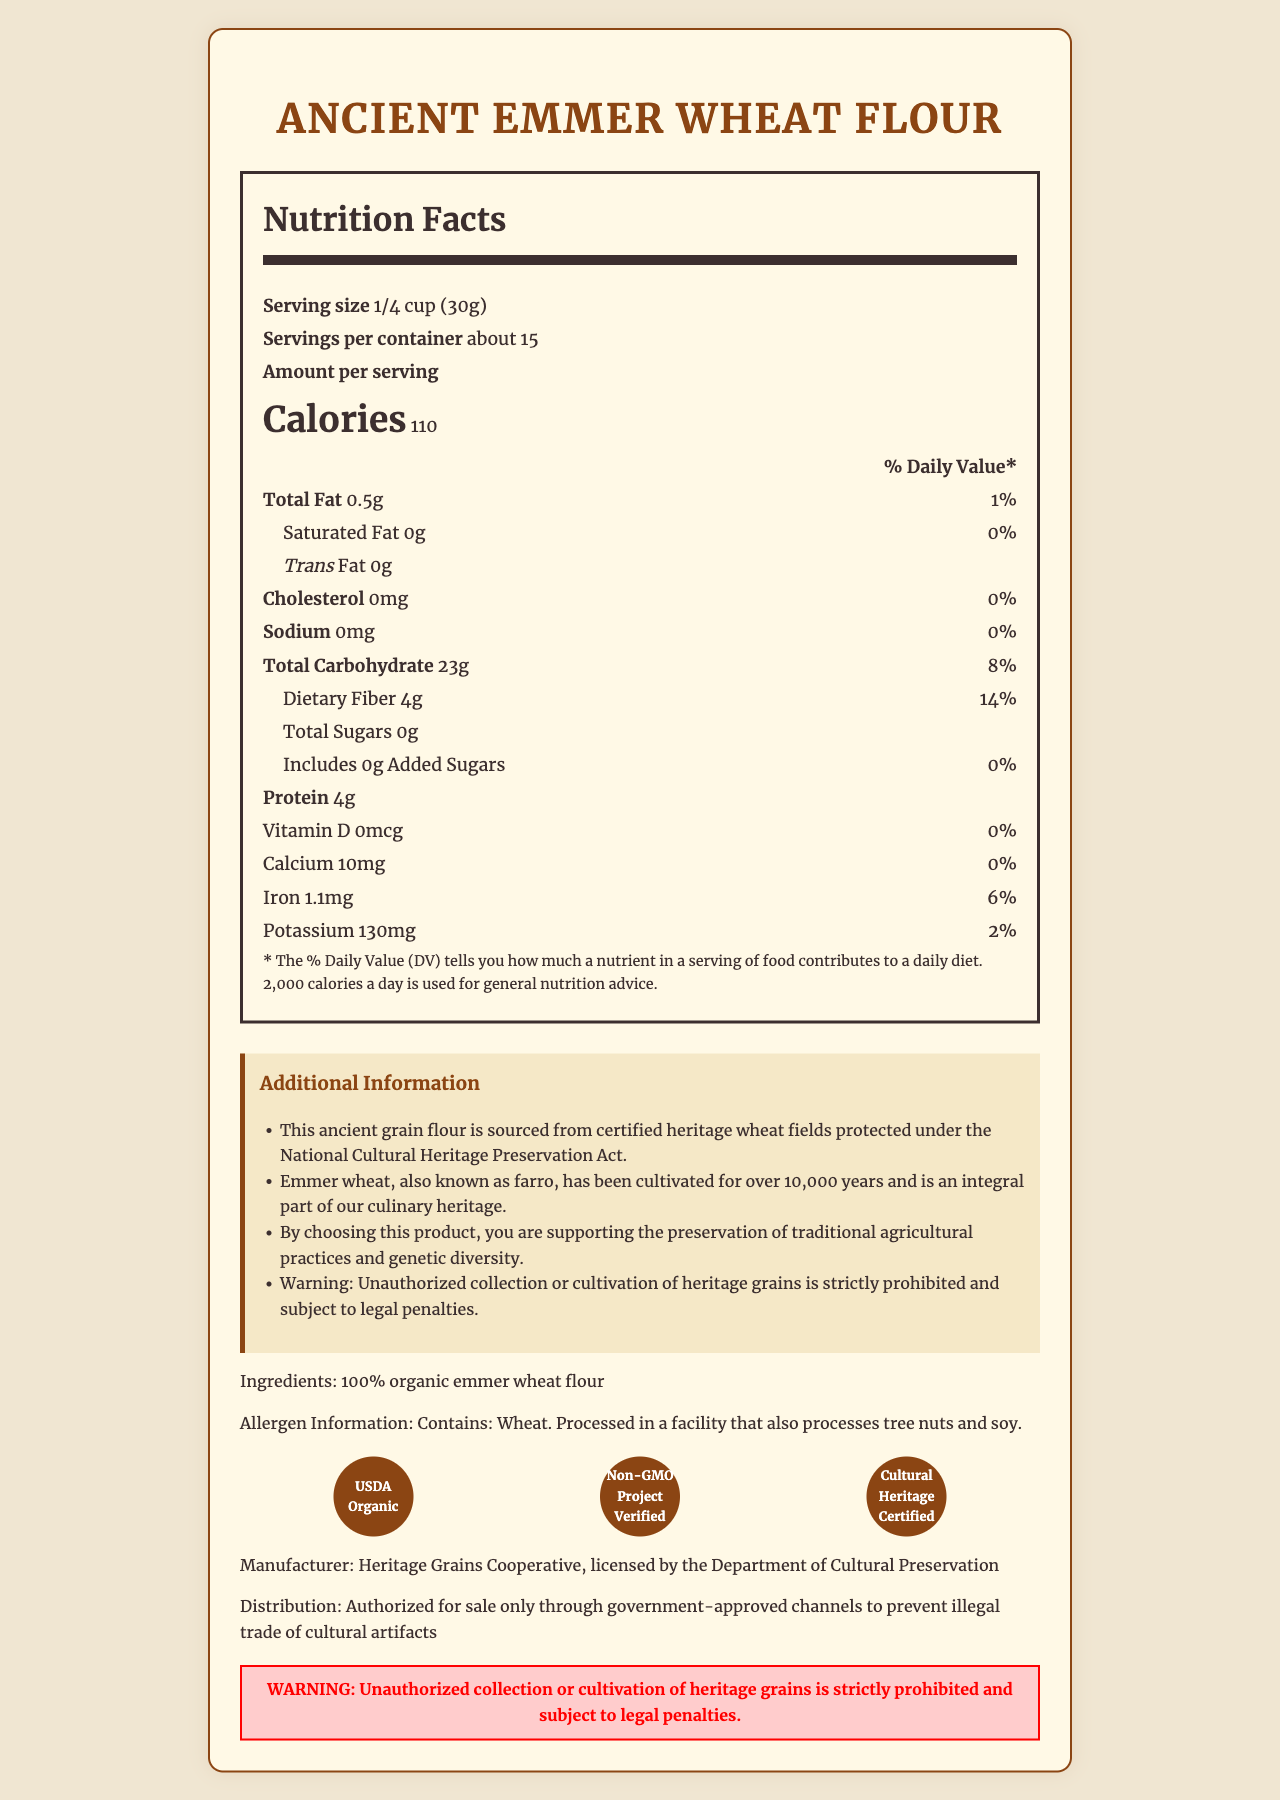what is the serving size? The serving size is explicitly mentioned in the nutrition label section as "1/4 cup (30g)".
Answer: 1/4 cup (30g) how many servings are there per container? The servings per container are indicated in the nutrition label section as "about 15".
Answer: about 15 what is the amount of dietary fiber per serving? The nutrition label states that each serving contains "Dietary Fiber 4g".
Answer: 4g how much iron is in a serving of this flour? The amount of iron per serving is listed as "Iron 1.1mg" in the nutrition label.
Answer: 1.1mg what certifications does the product have? These certifications are listed under the certification seals section in the document.
Answer: USDA Organic, Non-GMO Project Verified, Cultural Heritage Certified what is the total fat content per serving? The total fat content per serving is stated as "Total Fat 0.5g" in the nutrition label.
Answer: 0.5g is there any added sugar in the product? The nutrition label shows "Includes 0g Added Sugars", indicating there is no added sugar.
Answer: No who is the manufacturer of this product? The manufacturer is listed near the bottom of the document under the "Manufacturer" section.
Answer: Heritage Grains Cooperative, licensed by the Department of Cultural Preservation what is the primary ingredient in this product? The primary ingredient is listed under the "Ingredients" section.
Answer: 100% organic emmer wheat flour what is the main warning associated with this product? The warning section explicitly states this information.
Answer: Unauthorized collection or cultivation of heritage grains is strictly prohibited and subject to legal penalties. what is the daily value percentage of calcium per serving? The nutrition label mentions "Calcium 10mg" and "0%" as the daily value percentage for calcium.
Answer: 0% how many calories are in one serving of this product? A. 50 B. 110 C. 200 D. 300 The nutrition label indicates that one serving contains "Calories 110".
Answer: B how much potassium is in one serving of the product? A. 90mg B. 100mg C. 130mg D. 150mg The nutrition label lists "Potassium 130mg" as the amount per serving.
Answer: C does the product contain any cholesterol? The nutrition label shows "Cholesterol 0mg" indicating it contains no cholesterol.
Answer: No summarize the main idea of the document. This document summarizes the nutritional facts, additional information about the cultural heritage of the grain, ingredient and allergen details, certifications, manufacturer, and legal warnings.
Answer: The document provides detailed nutritional information for Ancient Emmer Wheat Flour, highlights its cultural significance, lists ingredient and allergen information, mentions certifications and manufacturing details, and includes a warning about unauthorized collection or cultivation. is there information on the vitamin C content in the product? The document does not mention any information regarding vitamin C content.
Answer: No explain the cultural significance of this product based on the document. This explanation is based on the additional information section detailing the heritage and preservation efforts related to the emmer wheat used in the product.
Answer: The product is made from emmer wheat, an ancient grain cultivated for over 10,000 years. It is sourced from certified heritage wheat fields protected under the National Cultural Heritage Preservation Act, emphasizing the preservation of traditional agricultural practices and genetic diversity. 